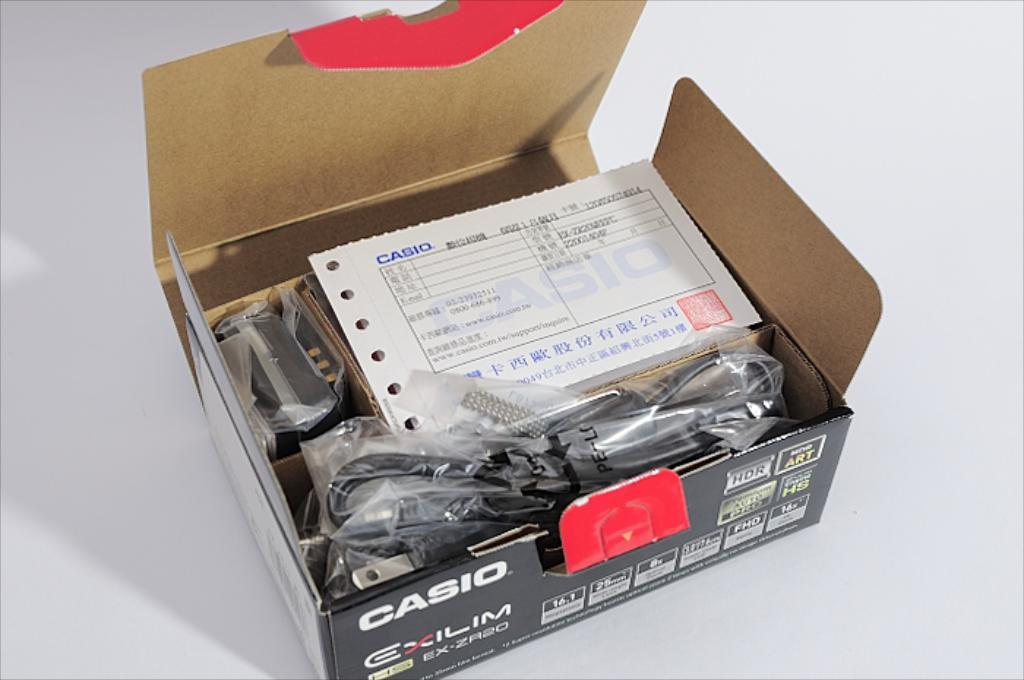What is the main object in the image? There is a Casio box in the image. What can be found inside the Casio box? There are wires and a receipt inside the Casio box. On what surface is the Casio box placed? The Casio box is placed on a white surface. Are there any icicles hanging from the Casio box in the image? No, there are no icicles present in the image. 